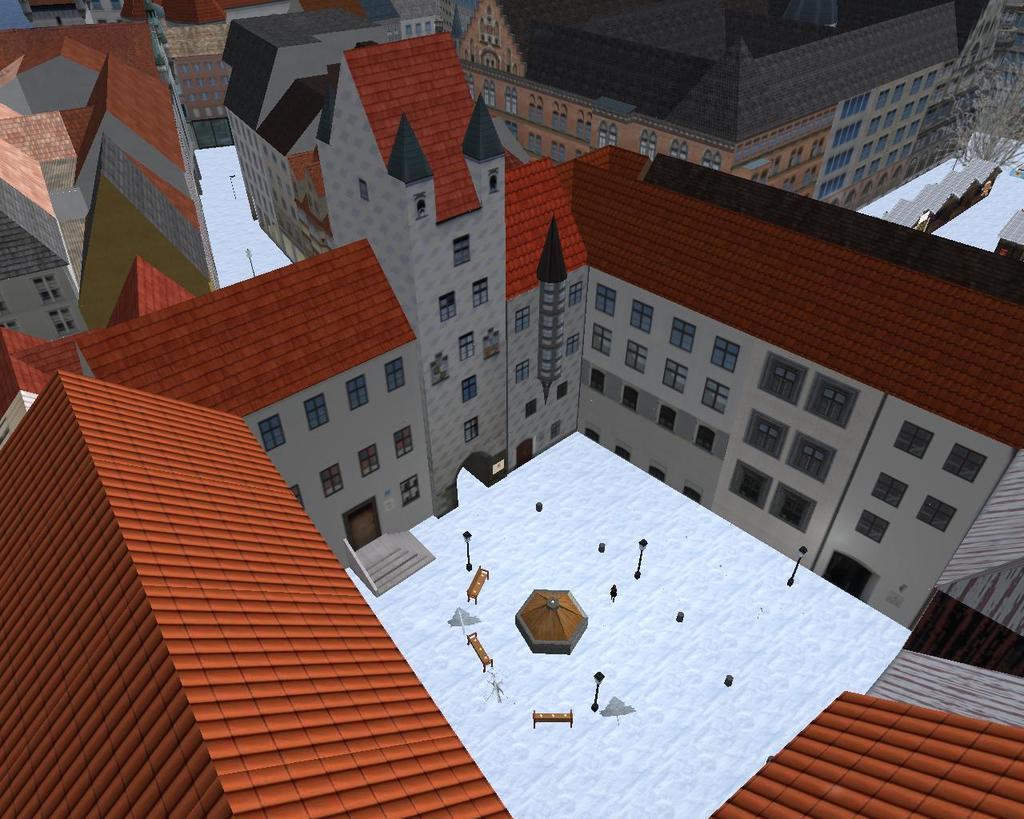How would you summarize this image in a sentence or two? In this picture we can observe a graphic. There are some houses with maroon and red color roofs. We can observe some snow on the land. 